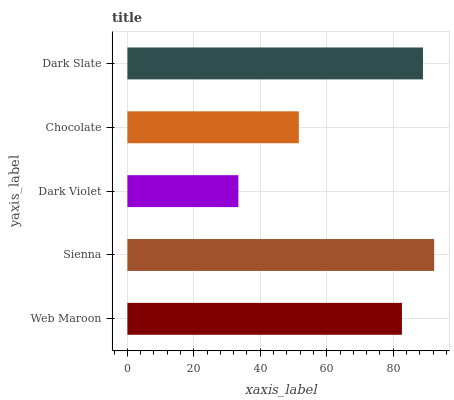Is Dark Violet the minimum?
Answer yes or no. Yes. Is Sienna the maximum?
Answer yes or no. Yes. Is Sienna the minimum?
Answer yes or no. No. Is Dark Violet the maximum?
Answer yes or no. No. Is Sienna greater than Dark Violet?
Answer yes or no. Yes. Is Dark Violet less than Sienna?
Answer yes or no. Yes. Is Dark Violet greater than Sienna?
Answer yes or no. No. Is Sienna less than Dark Violet?
Answer yes or no. No. Is Web Maroon the high median?
Answer yes or no. Yes. Is Web Maroon the low median?
Answer yes or no. Yes. Is Sienna the high median?
Answer yes or no. No. Is Dark Slate the low median?
Answer yes or no. No. 